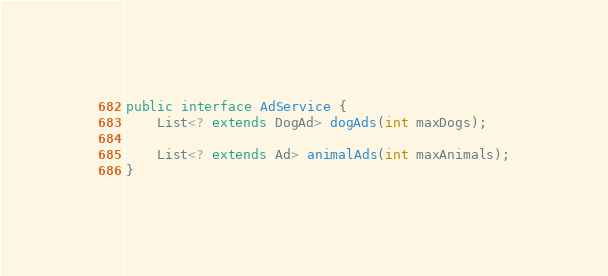Convert code to text. <code><loc_0><loc_0><loc_500><loc_500><_Java_>public interface AdService {
    List<? extends DogAd> dogAds(int maxDogs);

    List<? extends Ad> animalAds(int maxAnimals);
}</code> 